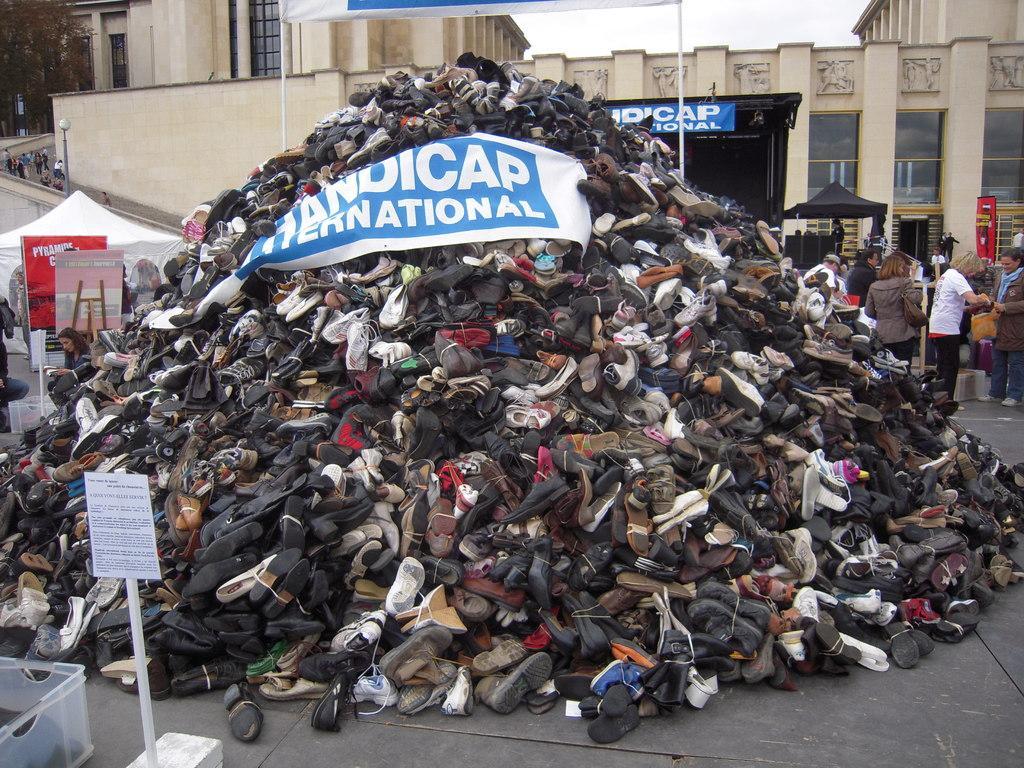Could you give a brief overview of what you see in this image? In this image I can see number of shoes, a building, number of poles, number of boards and on these boards, I can see something is written. On the both sides of the image I can see few tent houses and few people. On the left side of the image I can see two plastic containers, a light and on the top left corner of the image I can see a tree. I can also see the sky on the top right side of the image. 